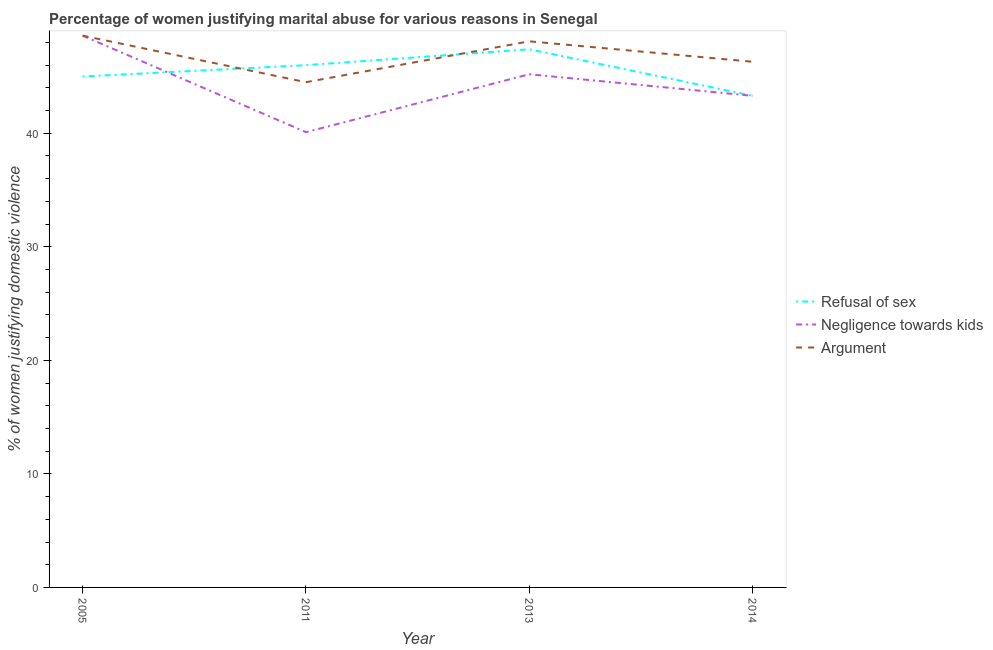How many different coloured lines are there?
Ensure brevity in your answer.  3. Is the number of lines equal to the number of legend labels?
Provide a succinct answer. Yes. What is the percentage of women justifying domestic violence due to refusal of sex in 2014?
Ensure brevity in your answer.  43.3. Across all years, what is the maximum percentage of women justifying domestic violence due to refusal of sex?
Offer a terse response. 47.4. Across all years, what is the minimum percentage of women justifying domestic violence due to arguments?
Your answer should be very brief. 44.5. In which year was the percentage of women justifying domestic violence due to negligence towards kids maximum?
Provide a short and direct response. 2005. In which year was the percentage of women justifying domestic violence due to refusal of sex minimum?
Give a very brief answer. 2014. What is the total percentage of women justifying domestic violence due to negligence towards kids in the graph?
Offer a very short reply. 177.2. What is the difference between the percentage of women justifying domestic violence due to refusal of sex in 2011 and that in 2014?
Make the answer very short. 2.7. What is the difference between the percentage of women justifying domestic violence due to arguments in 2005 and the percentage of women justifying domestic violence due to refusal of sex in 2014?
Provide a succinct answer. 5.3. What is the average percentage of women justifying domestic violence due to arguments per year?
Provide a succinct answer. 46.88. In the year 2013, what is the difference between the percentage of women justifying domestic violence due to negligence towards kids and percentage of women justifying domestic violence due to refusal of sex?
Offer a terse response. -2.2. What is the ratio of the percentage of women justifying domestic violence due to negligence towards kids in 2011 to that in 2014?
Ensure brevity in your answer.  0.93. Is the difference between the percentage of women justifying domestic violence due to negligence towards kids in 2005 and 2011 greater than the difference between the percentage of women justifying domestic violence due to arguments in 2005 and 2011?
Offer a very short reply. Yes. What is the difference between the highest and the second highest percentage of women justifying domestic violence due to negligence towards kids?
Ensure brevity in your answer.  3.4. Is the sum of the percentage of women justifying domestic violence due to negligence towards kids in 2005 and 2014 greater than the maximum percentage of women justifying domestic violence due to refusal of sex across all years?
Offer a terse response. Yes. Is the percentage of women justifying domestic violence due to negligence towards kids strictly greater than the percentage of women justifying domestic violence due to arguments over the years?
Give a very brief answer. No. Is the percentage of women justifying domestic violence due to negligence towards kids strictly less than the percentage of women justifying domestic violence due to refusal of sex over the years?
Ensure brevity in your answer.  No. How many lines are there?
Provide a succinct answer. 3. What is the difference between two consecutive major ticks on the Y-axis?
Your answer should be compact. 10. Does the graph contain any zero values?
Keep it short and to the point. No. What is the title of the graph?
Make the answer very short. Percentage of women justifying marital abuse for various reasons in Senegal. What is the label or title of the X-axis?
Your response must be concise. Year. What is the label or title of the Y-axis?
Offer a terse response. % of women justifying domestic violence. What is the % of women justifying domestic violence in Refusal of sex in 2005?
Provide a succinct answer. 45. What is the % of women justifying domestic violence of Negligence towards kids in 2005?
Ensure brevity in your answer.  48.6. What is the % of women justifying domestic violence of Argument in 2005?
Offer a very short reply. 48.6. What is the % of women justifying domestic violence in Negligence towards kids in 2011?
Your answer should be very brief. 40.1. What is the % of women justifying domestic violence in Argument in 2011?
Offer a terse response. 44.5. What is the % of women justifying domestic violence in Refusal of sex in 2013?
Offer a terse response. 47.4. What is the % of women justifying domestic violence of Negligence towards kids in 2013?
Your answer should be compact. 45.2. What is the % of women justifying domestic violence in Argument in 2013?
Make the answer very short. 48.1. What is the % of women justifying domestic violence in Refusal of sex in 2014?
Keep it short and to the point. 43.3. What is the % of women justifying domestic violence of Negligence towards kids in 2014?
Your response must be concise. 43.3. What is the % of women justifying domestic violence in Argument in 2014?
Make the answer very short. 46.3. Across all years, what is the maximum % of women justifying domestic violence in Refusal of sex?
Your response must be concise. 47.4. Across all years, what is the maximum % of women justifying domestic violence in Negligence towards kids?
Offer a very short reply. 48.6. Across all years, what is the maximum % of women justifying domestic violence in Argument?
Make the answer very short. 48.6. Across all years, what is the minimum % of women justifying domestic violence in Refusal of sex?
Provide a short and direct response. 43.3. Across all years, what is the minimum % of women justifying domestic violence in Negligence towards kids?
Provide a succinct answer. 40.1. Across all years, what is the minimum % of women justifying domestic violence in Argument?
Your answer should be very brief. 44.5. What is the total % of women justifying domestic violence in Refusal of sex in the graph?
Your answer should be very brief. 181.7. What is the total % of women justifying domestic violence of Negligence towards kids in the graph?
Your answer should be compact. 177.2. What is the total % of women justifying domestic violence of Argument in the graph?
Keep it short and to the point. 187.5. What is the difference between the % of women justifying domestic violence of Argument in 2005 and that in 2011?
Give a very brief answer. 4.1. What is the difference between the % of women justifying domestic violence in Argument in 2005 and that in 2013?
Make the answer very short. 0.5. What is the difference between the % of women justifying domestic violence in Negligence towards kids in 2005 and that in 2014?
Your response must be concise. 5.3. What is the difference between the % of women justifying domestic violence of Argument in 2005 and that in 2014?
Keep it short and to the point. 2.3. What is the difference between the % of women justifying domestic violence in Refusal of sex in 2011 and that in 2014?
Your answer should be very brief. 2.7. What is the difference between the % of women justifying domestic violence of Refusal of sex in 2005 and the % of women justifying domestic violence of Argument in 2011?
Make the answer very short. 0.5. What is the difference between the % of women justifying domestic violence of Refusal of sex in 2005 and the % of women justifying domestic violence of Argument in 2013?
Offer a terse response. -3.1. What is the difference between the % of women justifying domestic violence in Negligence towards kids in 2005 and the % of women justifying domestic violence in Argument in 2013?
Your answer should be compact. 0.5. What is the difference between the % of women justifying domestic violence in Refusal of sex in 2005 and the % of women justifying domestic violence in Negligence towards kids in 2014?
Give a very brief answer. 1.7. What is the difference between the % of women justifying domestic violence in Refusal of sex in 2005 and the % of women justifying domestic violence in Argument in 2014?
Your answer should be compact. -1.3. What is the difference between the % of women justifying domestic violence of Negligence towards kids in 2005 and the % of women justifying domestic violence of Argument in 2014?
Your answer should be very brief. 2.3. What is the difference between the % of women justifying domestic violence of Negligence towards kids in 2011 and the % of women justifying domestic violence of Argument in 2013?
Your answer should be very brief. -8. What is the difference between the % of women justifying domestic violence in Refusal of sex in 2011 and the % of women justifying domestic violence in Negligence towards kids in 2014?
Your answer should be very brief. 2.7. What is the difference between the % of women justifying domestic violence in Refusal of sex in 2013 and the % of women justifying domestic violence in Negligence towards kids in 2014?
Provide a succinct answer. 4.1. What is the average % of women justifying domestic violence of Refusal of sex per year?
Your answer should be very brief. 45.42. What is the average % of women justifying domestic violence in Negligence towards kids per year?
Your answer should be very brief. 44.3. What is the average % of women justifying domestic violence of Argument per year?
Keep it short and to the point. 46.88. In the year 2005, what is the difference between the % of women justifying domestic violence in Refusal of sex and % of women justifying domestic violence in Negligence towards kids?
Your response must be concise. -3.6. In the year 2005, what is the difference between the % of women justifying domestic violence of Refusal of sex and % of women justifying domestic violence of Argument?
Make the answer very short. -3.6. In the year 2005, what is the difference between the % of women justifying domestic violence in Negligence towards kids and % of women justifying domestic violence in Argument?
Make the answer very short. 0. In the year 2011, what is the difference between the % of women justifying domestic violence in Refusal of sex and % of women justifying domestic violence in Argument?
Make the answer very short. 1.5. In the year 2013, what is the difference between the % of women justifying domestic violence in Refusal of sex and % of women justifying domestic violence in Argument?
Make the answer very short. -0.7. In the year 2013, what is the difference between the % of women justifying domestic violence in Negligence towards kids and % of women justifying domestic violence in Argument?
Provide a succinct answer. -2.9. In the year 2014, what is the difference between the % of women justifying domestic violence of Refusal of sex and % of women justifying domestic violence of Argument?
Your answer should be very brief. -3. What is the ratio of the % of women justifying domestic violence in Refusal of sex in 2005 to that in 2011?
Make the answer very short. 0.98. What is the ratio of the % of women justifying domestic violence of Negligence towards kids in 2005 to that in 2011?
Keep it short and to the point. 1.21. What is the ratio of the % of women justifying domestic violence in Argument in 2005 to that in 2011?
Your response must be concise. 1.09. What is the ratio of the % of women justifying domestic violence in Refusal of sex in 2005 to that in 2013?
Provide a short and direct response. 0.95. What is the ratio of the % of women justifying domestic violence of Negligence towards kids in 2005 to that in 2013?
Keep it short and to the point. 1.08. What is the ratio of the % of women justifying domestic violence in Argument in 2005 to that in 2013?
Ensure brevity in your answer.  1.01. What is the ratio of the % of women justifying domestic violence of Refusal of sex in 2005 to that in 2014?
Ensure brevity in your answer.  1.04. What is the ratio of the % of women justifying domestic violence of Negligence towards kids in 2005 to that in 2014?
Provide a succinct answer. 1.12. What is the ratio of the % of women justifying domestic violence in Argument in 2005 to that in 2014?
Your answer should be very brief. 1.05. What is the ratio of the % of women justifying domestic violence in Refusal of sex in 2011 to that in 2013?
Your answer should be very brief. 0.97. What is the ratio of the % of women justifying domestic violence in Negligence towards kids in 2011 to that in 2013?
Keep it short and to the point. 0.89. What is the ratio of the % of women justifying domestic violence of Argument in 2011 to that in 2013?
Offer a very short reply. 0.93. What is the ratio of the % of women justifying domestic violence in Refusal of sex in 2011 to that in 2014?
Offer a very short reply. 1.06. What is the ratio of the % of women justifying domestic violence in Negligence towards kids in 2011 to that in 2014?
Keep it short and to the point. 0.93. What is the ratio of the % of women justifying domestic violence of Argument in 2011 to that in 2014?
Your answer should be compact. 0.96. What is the ratio of the % of women justifying domestic violence of Refusal of sex in 2013 to that in 2014?
Your answer should be very brief. 1.09. What is the ratio of the % of women justifying domestic violence of Negligence towards kids in 2013 to that in 2014?
Offer a very short reply. 1.04. What is the ratio of the % of women justifying domestic violence of Argument in 2013 to that in 2014?
Offer a terse response. 1.04. What is the difference between the highest and the second highest % of women justifying domestic violence in Refusal of sex?
Your answer should be very brief. 1.4. What is the difference between the highest and the second highest % of women justifying domestic violence of Negligence towards kids?
Your answer should be compact. 3.4. What is the difference between the highest and the second highest % of women justifying domestic violence of Argument?
Make the answer very short. 0.5. What is the difference between the highest and the lowest % of women justifying domestic violence of Negligence towards kids?
Offer a terse response. 8.5. 